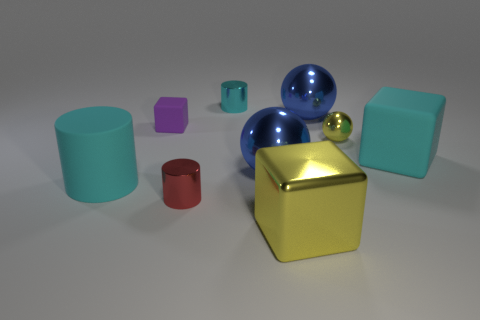Subtract all yellow balls. Subtract all gray cylinders. How many balls are left? 2 Subtract all cylinders. How many objects are left? 6 Add 3 small metallic cylinders. How many small metallic cylinders exist? 5 Subtract 0 gray balls. How many objects are left? 9 Subtract all cyan shiny cylinders. Subtract all big blue balls. How many objects are left? 6 Add 9 tiny cyan things. How many tiny cyan things are left? 10 